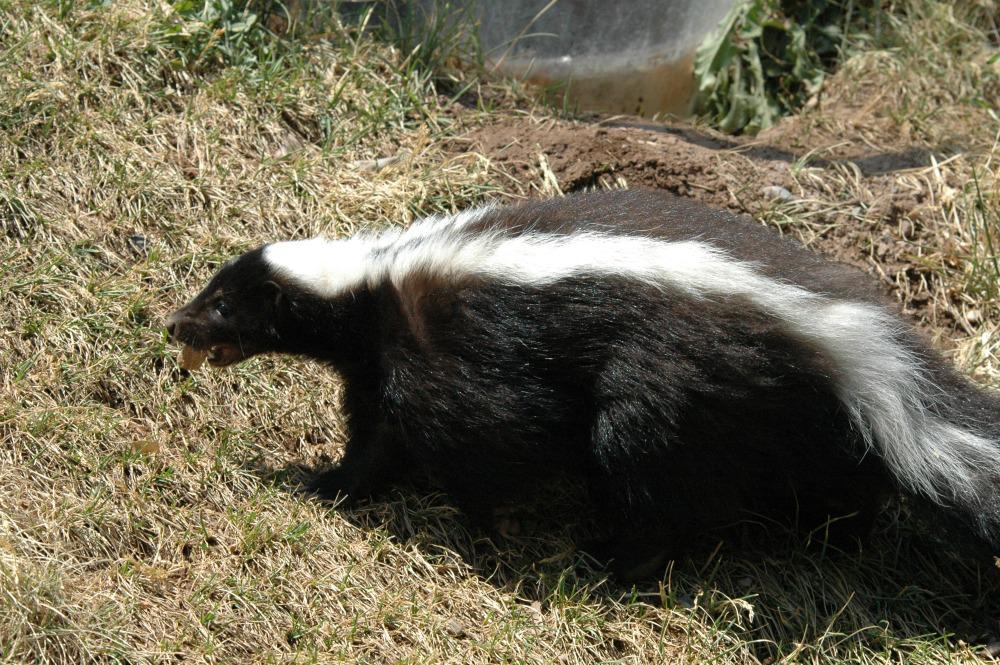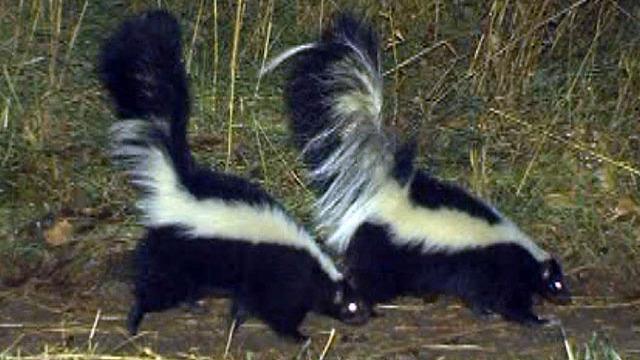The first image is the image on the left, the second image is the image on the right. Examine the images to the left and right. Is the description "One image contains a single skunk on all fours, and the other image features two side-by-side skunks with look-alike coloring and walking poses." accurate? Answer yes or no. Yes. The first image is the image on the left, the second image is the image on the right. For the images displayed, is the sentence "There are three skunks." factually correct? Answer yes or no. Yes. 